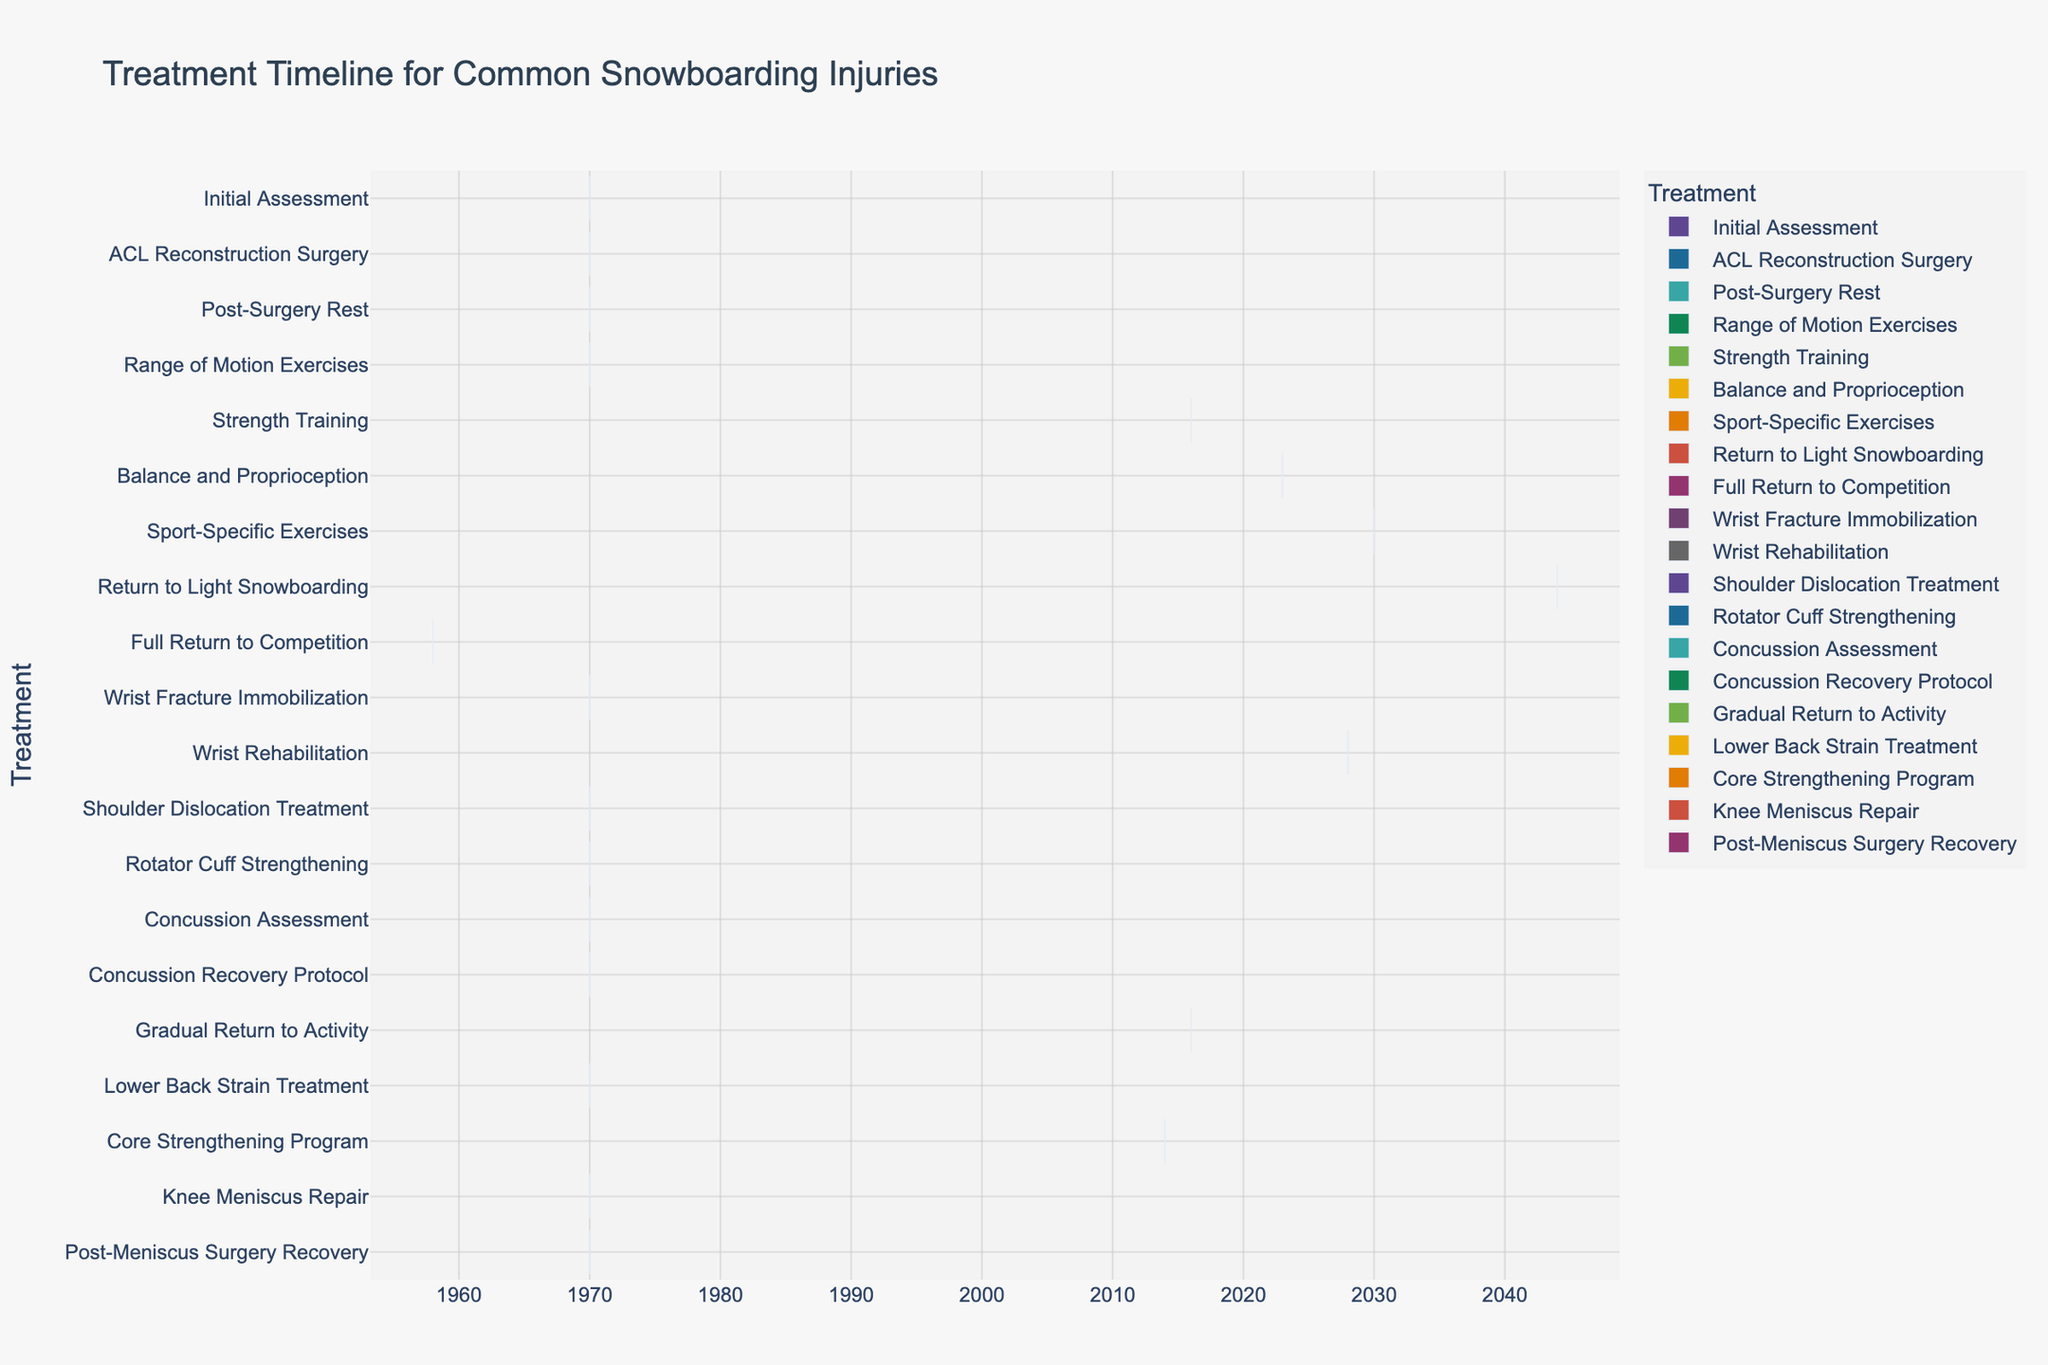What is the title of the Gantt chart? The title can be found at the top of the chart. It summarizes what the chart is about.
Answer: Treatment Timeline for Common Snowboarding Injuries How long does the 'Post-Surgery Rest' phase last? The 'Post-Surgery Rest' phase starts at day 2 and ends at day 9. The duration can be calculated as 9 - 2 = 7 days.
Answer: 7 days Which treatment has the longest duration? By comparing the duration of each treatment visually, the treatment with the longest bar on the chart is the one with the longest duration.
Answer: Full Return to Competition During which time period does 'Strength Training' occur? This can be determined by looking at the start and end times of the 'Strength Training' bar on the chart. It starts at day 16 and ends at day 37.
Answer: Day 16 to Day 37 What activities happen concurrently with 'ACL Reconstruction Surgery'? Look at the bars that overlap the timeframe of 'ACL Reconstruction Surgery' from day 1 to day 2. These activities include 'Concussion Assessment' and 'Knee Meniscus Repair'.
Answer: Concussion Assessment, Knee Meniscus Repair What is the combined duration of 'Balance and Proprioception' and 'Sport-Specific Exercises'? 'Balance and Proprioception' lasts from day 23 to day 44 (21 days) and 'Sport-Specific Exercises' lasts from day 30 to day 51 (21 days). Their combined duration is 21 + 21 = 42 days.
Answer: 42 days Which phase directly follows 'Rotator Cuff Strengthening'? By examining the order of bars on the y-axis, 'Rotator Cuff Strengthening' is followed by 'Concussion Assessment', but they overlap. So, we mean the next phase without overlap, which would be 'Return to Light Snowboarding' starting from day 44.
Answer: Return to Light Snowboarding Compare the duration of 'Wrist Fracture Immobilization' to 'Lower Back Strain Treatment'. Which is longer, and by how much? 'Wrist Fracture Immobilization' lasts from day 0 to day 28, which is 28 days. 'Lower Back Strain Treatment' lasts from day 0 to day 14, which is 14 days. The difference is 28 - 14 = 14 days, so 'Wrist Fracture Immobilization' is longer by 14 days.
Answer: 14 days What is the total duration of the entire timeline depicted in the Gantt chart? The entire timeline starts at day 0 and ends at day 72, as indicated by the 'Full Return to Competition'. The total duration can be calculated as 72 - 0 = 72 days.
Answer: 72 days 